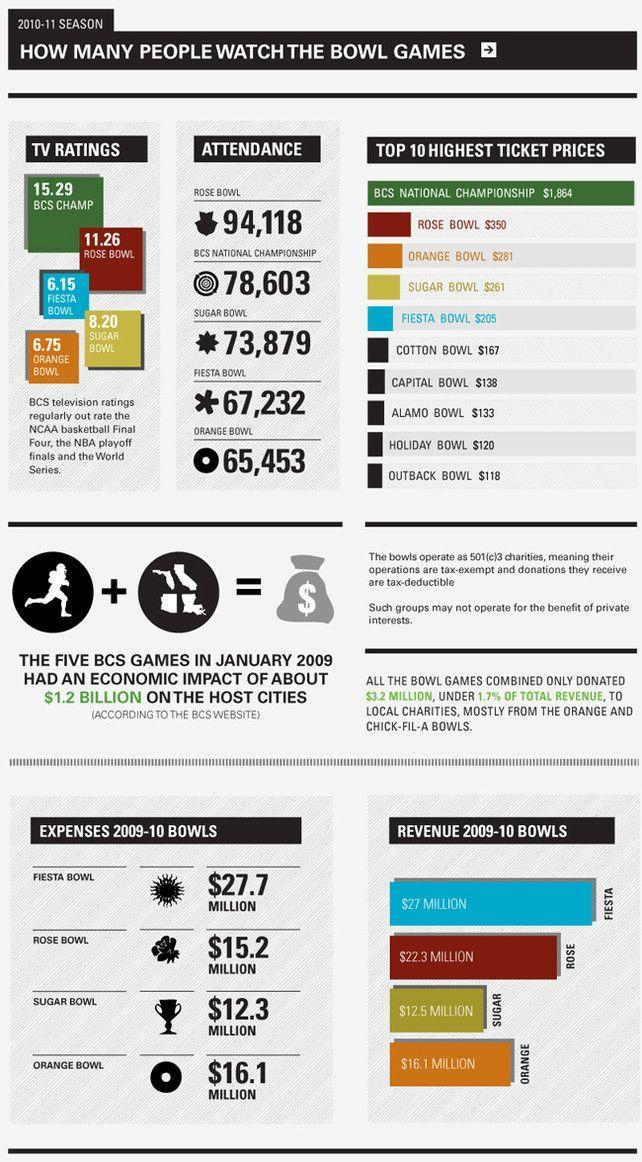How many more people attended fiesta bowl than orange bowl?
Answer the question with a short phrase. 1779 Which game has the sixth highest ticket price? cotton bowl How much more revenue did the rose bowl get compared to its expenditure in 2009-2010? $7.1 million How many more people attended Rose bowl than sugar bowl? 20,239 How much more revenue did the rose bowl get compared to the revenue from sugar bowl in 2009-2010? $9.8 million What is the difference in ticket price between sugar bowl and cotton bowl? $94 What is the attendance for fiesta bowl? 67,232 Which game has the eighth highest ticket price? alamo bowl How much more revenue did the fiesta bowl get compared to the revenue from sugar bowl in 2009-2010? $14.5 million How much more revenue did the sugar bowl get compared to its expenditure in 2009-2010? $.2 million Which game has the fourth highest ticket price? sugar bowl What is the difference in ticket price between capital bowl and alamo bowl? $5 Which game has the fifth most attendance among the games? orange bowl What is the attendance for sugar bowl? 73,879 Which game has the fourth most attendance among the games? Fiesta bowl What is the difference in ticket price between capital bowl and holiday bowl? $18 Which has the second best TV Ratings? Rose Bowl What is the difference in ticket price between fiesta bowl and orange bowl? $76 